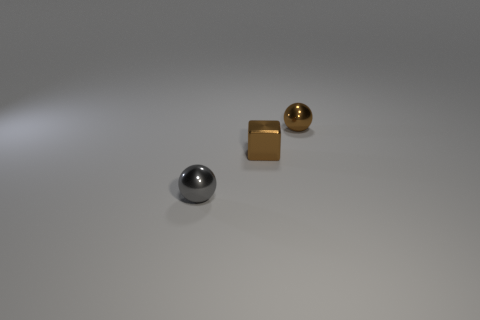Add 1 gray metallic balls. How many objects exist? 4 Subtract all spheres. How many objects are left? 1 Subtract all large green balls. Subtract all metallic balls. How many objects are left? 1 Add 2 metal objects. How many metal objects are left? 5 Add 3 small things. How many small things exist? 6 Subtract 0 red cubes. How many objects are left? 3 